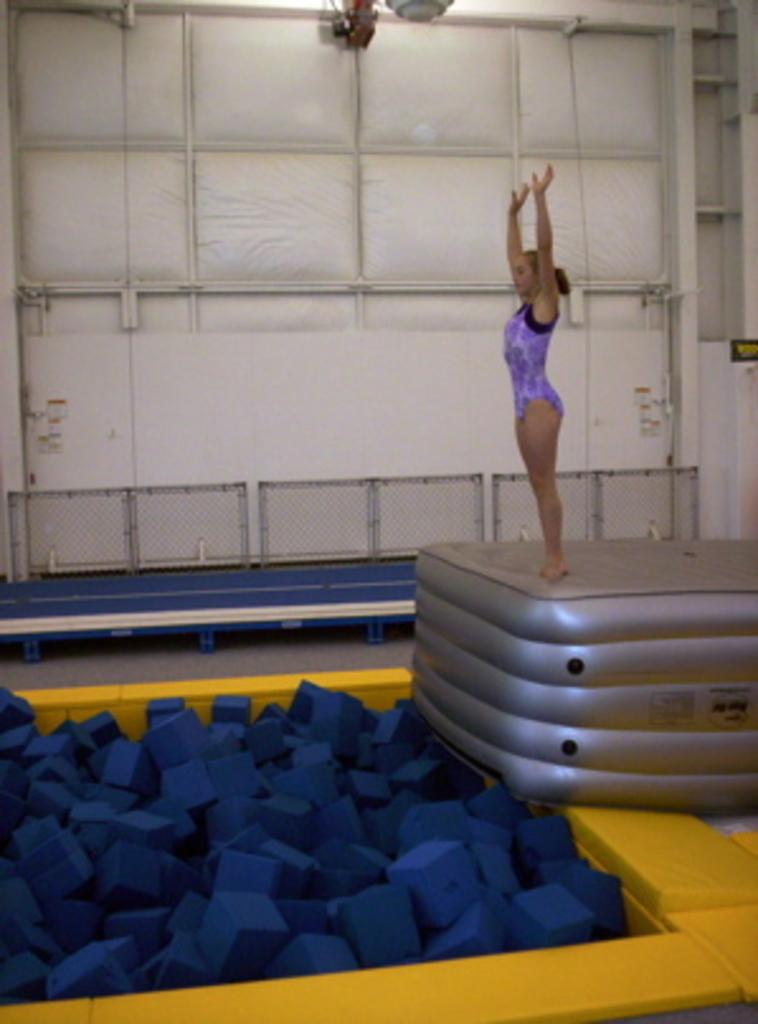What is the main subject of the image? The main subject of the image is a man. What is the man standing on in the image? The man is standing on an air bed. What is the man doing with his hands in the image? The man is raising his hands up. What type of kettle is the man using to perform a religious ritual in the image? There is no kettle or religious ritual present in the image. 